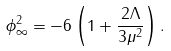Convert formula to latex. <formula><loc_0><loc_0><loc_500><loc_500>\phi _ { \infty } ^ { 2 } = - 6 \left ( 1 + \frac { 2 \Lambda } { 3 \mu ^ { 2 } } \right ) .</formula> 